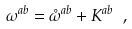<formula> <loc_0><loc_0><loc_500><loc_500>\omega ^ { a b } = \mathring { \omega } ^ { a b } + K ^ { a b } \ ,</formula> 